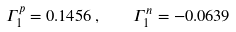<formula> <loc_0><loc_0><loc_500><loc_500>\Gamma _ { 1 } ^ { p } = 0 . 1 4 5 6 \, , \quad \Gamma _ { 1 } ^ { n } = - 0 . 0 6 3 9</formula> 